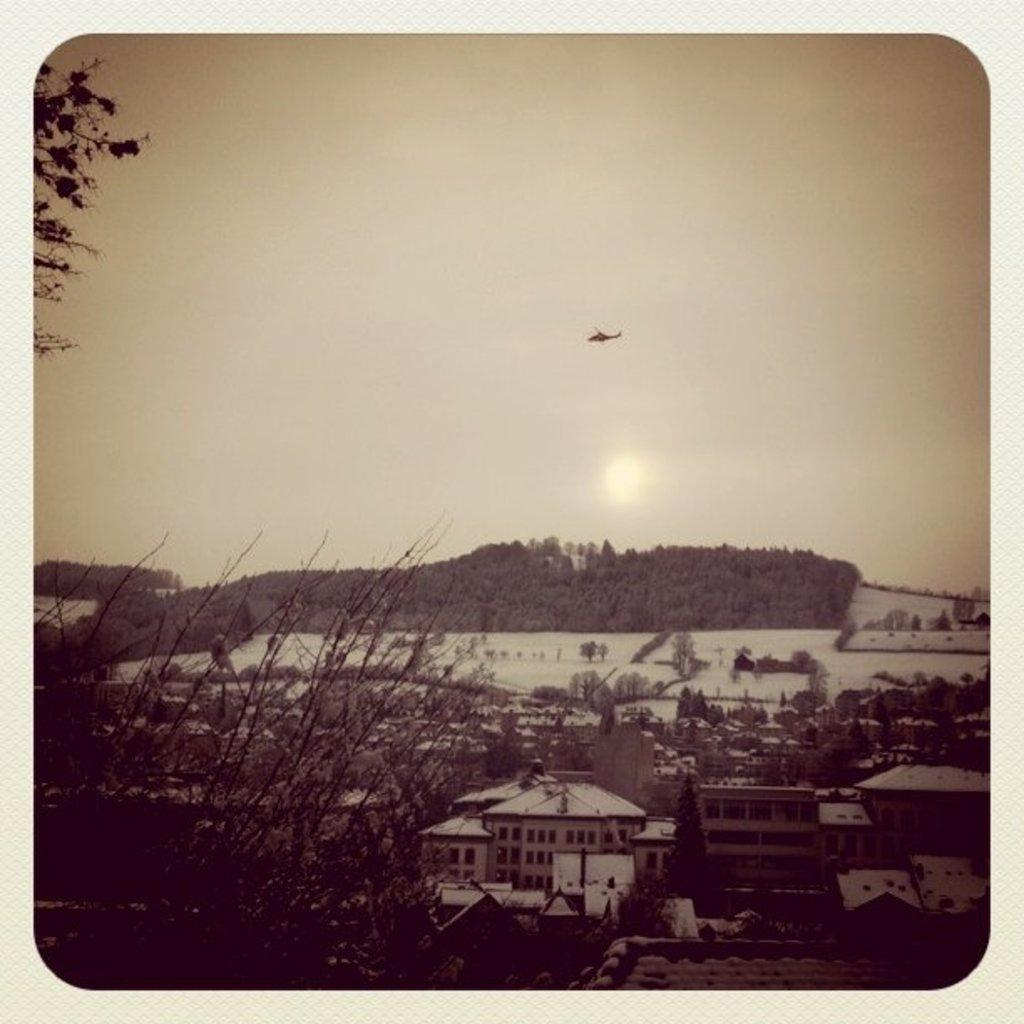What type of structures can be seen in the image? There are buildings in the image. What other natural elements are present in the image? There are trees in the image. What can be seen in the background of the image? There is an airplane flying in the background of the image, and the sky is also visible. Where is the tray located in the image? There is no tray present in the image. Can you describe the tiger's behavior in the image? There is no tiger present in the image, so its behavior cannot be described. 